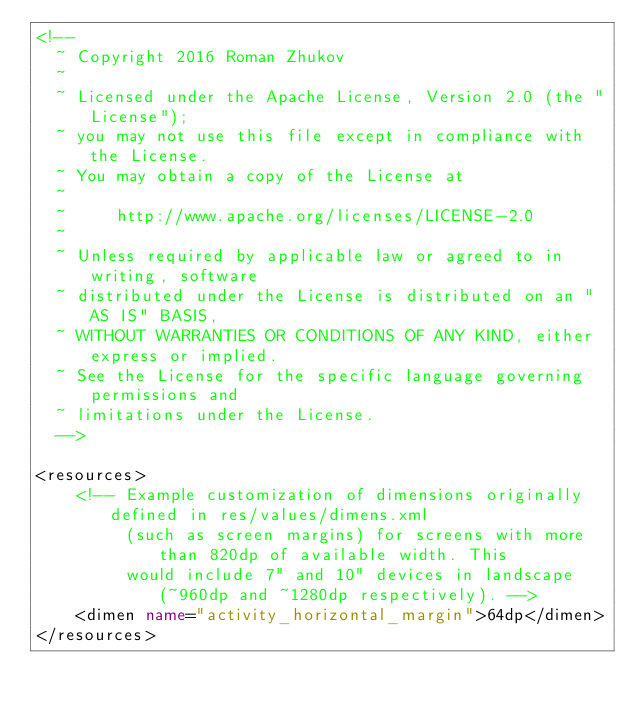Convert code to text. <code><loc_0><loc_0><loc_500><loc_500><_XML_><!--
  ~ Copyright 2016 Roman Zhukov
  ~
  ~ Licensed under the Apache License, Version 2.0 (the "License");
  ~ you may not use this file except in compliance with the License.
  ~ You may obtain a copy of the License at
  ~
  ~     http://www.apache.org/licenses/LICENSE-2.0
  ~
  ~ Unless required by applicable law or agreed to in writing, software
  ~ distributed under the License is distributed on an "AS IS" BASIS,
  ~ WITHOUT WARRANTIES OR CONDITIONS OF ANY KIND, either express or implied.
  ~ See the License for the specific language governing permissions and
  ~ limitations under the License.
  -->

<resources>
    <!-- Example customization of dimensions originally defined in res/values/dimens.xml
         (such as screen margins) for screens with more than 820dp of available width. This
         would include 7" and 10" devices in landscape (~960dp and ~1280dp respectively). -->
    <dimen name="activity_horizontal_margin">64dp</dimen>
</resources>
</code> 